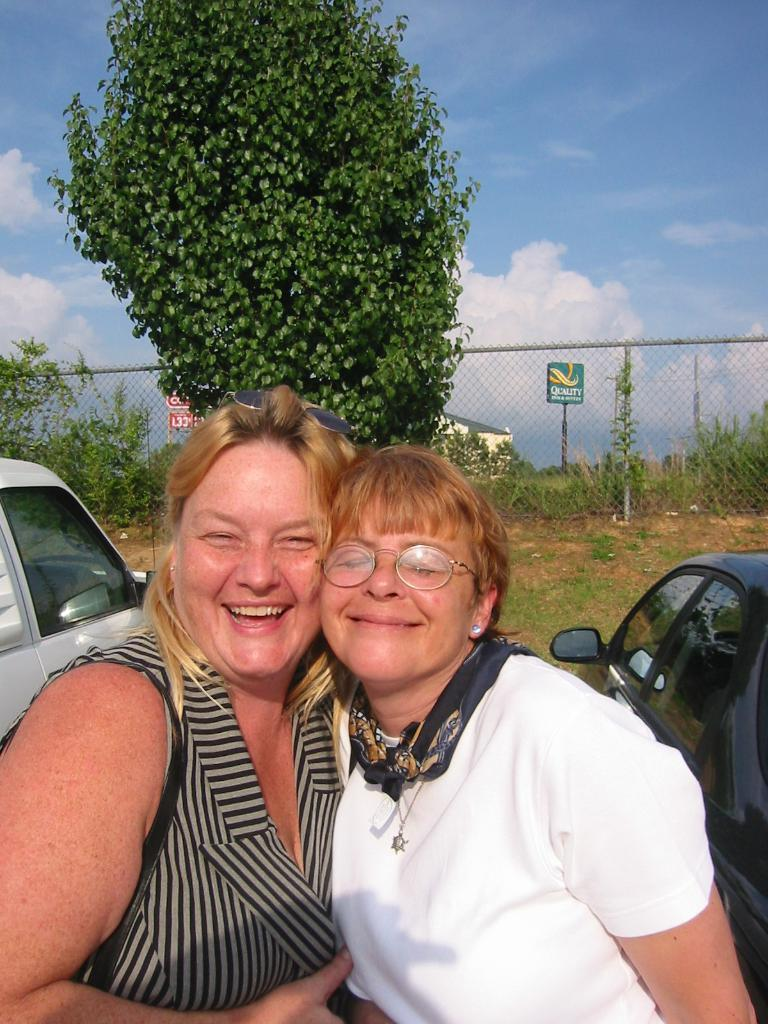How many people are in the image? There are two persons in the image. What is the facial expression of the persons in the image? The persons are smiling. What type of vehicles can be seen in the image? There are cars in the image. What type of vegetation is present in the image? There are plants and a tree in the image. What type of barrier is visible in the image? There is a wire fence in the image. What is visible in the background of the image? The sky is visible in the background of the image. What type of pollution can be seen in the image? There is no visible pollution in the image. What type of board is being used by the daughter in the image? There is no daughter or board present in the image. 